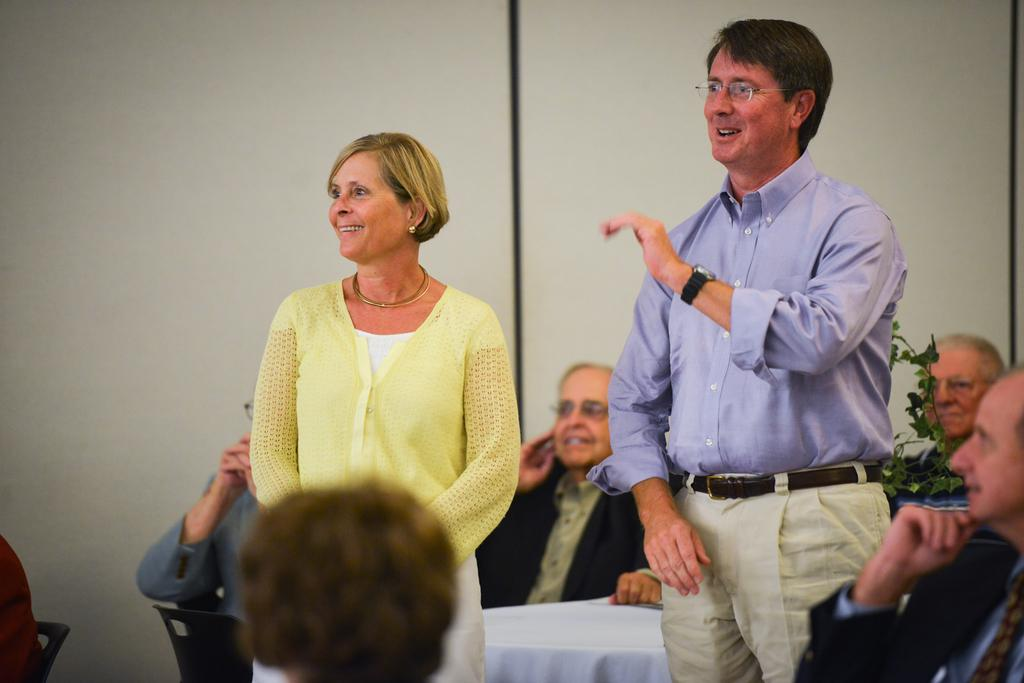What is located behind the persons in the image? There are two persons in the middle of the image, and they are standing in front of a wall. How many persons are visible in the image? There are persons in front of the table and two persons in the middle of the image, making a total of at least three persons visible. What are the two persons in the middle of the image wearing? The two persons in the middle of the image are wearing clothes. What type of pets can be seen playing with a pail in the image? There are no pets or pails present in the image; it features persons standing in front of a wall. What is the cause of the war depicted in the image? There is no war depicted in the image; it features persons standing in front of a wall. 